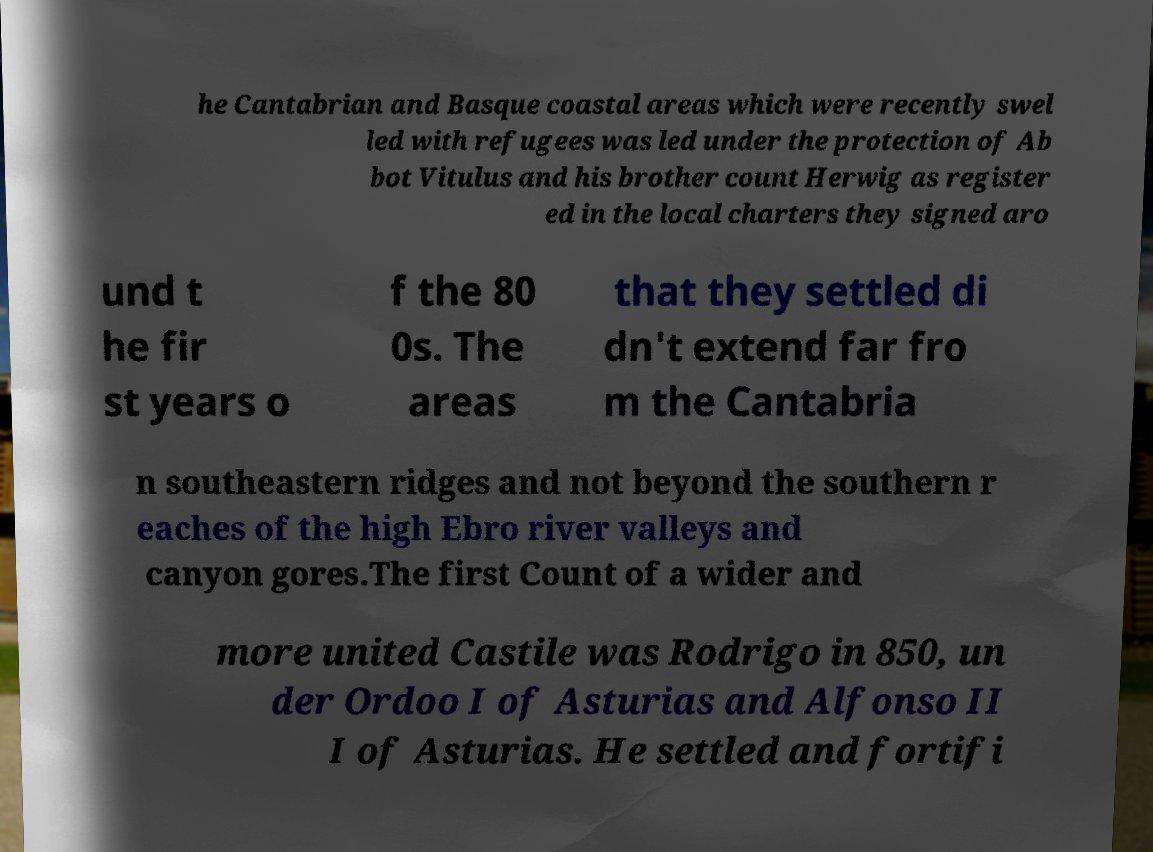For documentation purposes, I need the text within this image transcribed. Could you provide that? he Cantabrian and Basque coastal areas which were recently swel led with refugees was led under the protection of Ab bot Vitulus and his brother count Herwig as register ed in the local charters they signed aro und t he fir st years o f the 80 0s. The areas that they settled di dn't extend far fro m the Cantabria n southeastern ridges and not beyond the southern r eaches of the high Ebro river valleys and canyon gores.The first Count of a wider and more united Castile was Rodrigo in 850, un der Ordoo I of Asturias and Alfonso II I of Asturias. He settled and fortifi 